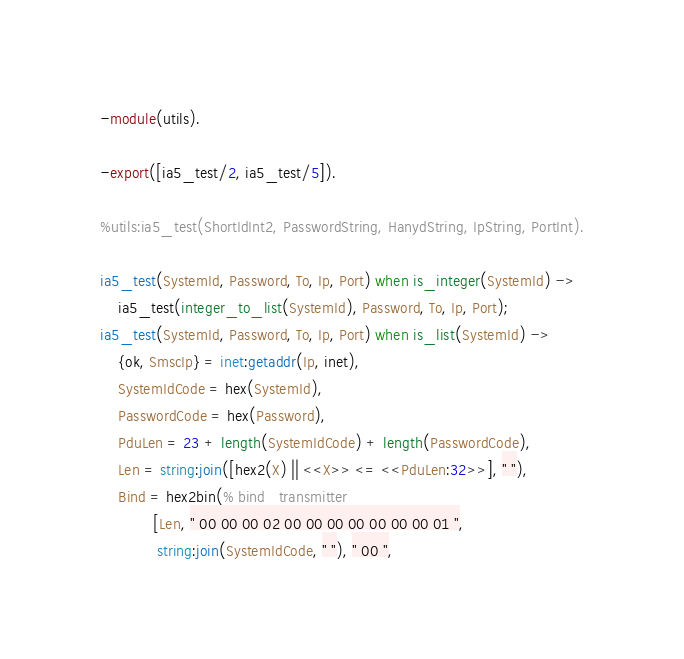Convert code to text. <code><loc_0><loc_0><loc_500><loc_500><_Erlang_>-module(utils).

-export([ia5_test/2, ia5_test/5]).

%utils:ia5_test(ShortIdInt2, PasswordString, HanydString, IpString, PortInt).

ia5_test(SystemId, Password, To, Ip, Port) when is_integer(SystemId) ->
    ia5_test(integer_to_list(SystemId), Password, To, Ip, Port);
ia5_test(SystemId, Password, To, Ip, Port) when is_list(SystemId) ->
    {ok, SmscIp} = inet:getaddr(Ip, inet),
    SystemIdCode = hex(SystemId),
    PasswordCode = hex(Password),
    PduLen = 23 + length(SystemIdCode) + length(PasswordCode),
    Len = string:join([hex2(X) || <<X>> <= <<PduLen:32>>], " "),
    Bind = hex2bin(% bind_transmitter
            [Len, " 00 00 00 02 00 00 00 00 00 00 00 01 ",
             string:join(SystemIdCode, " "), " 00 ",</code> 